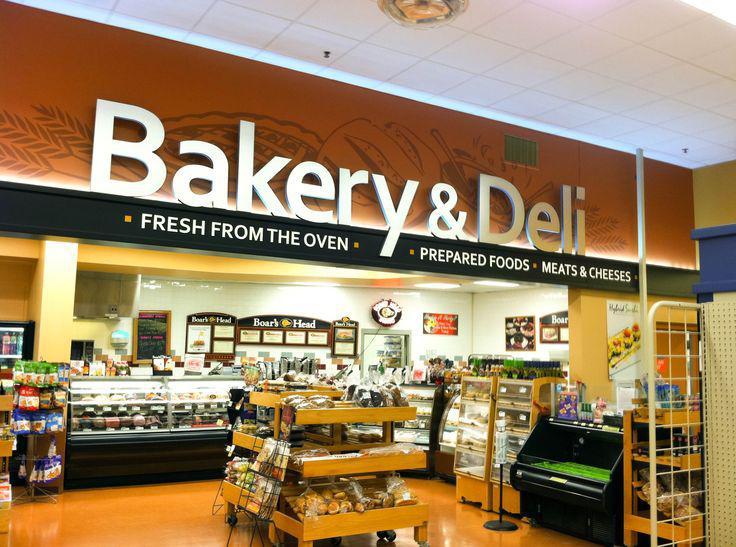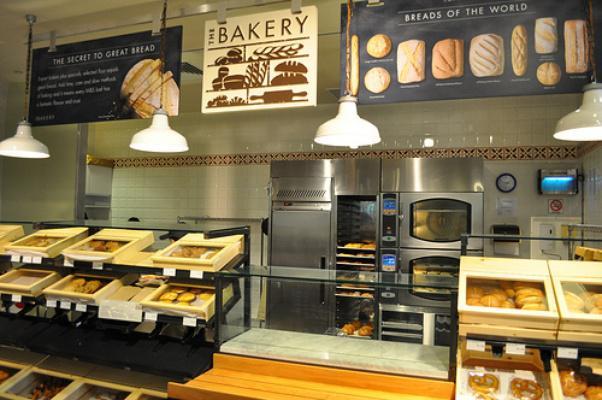The first image is the image on the left, the second image is the image on the right. Evaluate the accuracy of this statement regarding the images: "The right image contains at least 2 pendant style lamps above the bakery case.". Is it true? Answer yes or no. Yes. The first image is the image on the left, the second image is the image on the right. Analyze the images presented: Is the assertion "In at least one image you can see a dropped or lowered all white hood lamp near the bakery." valid? Answer yes or no. Yes. 